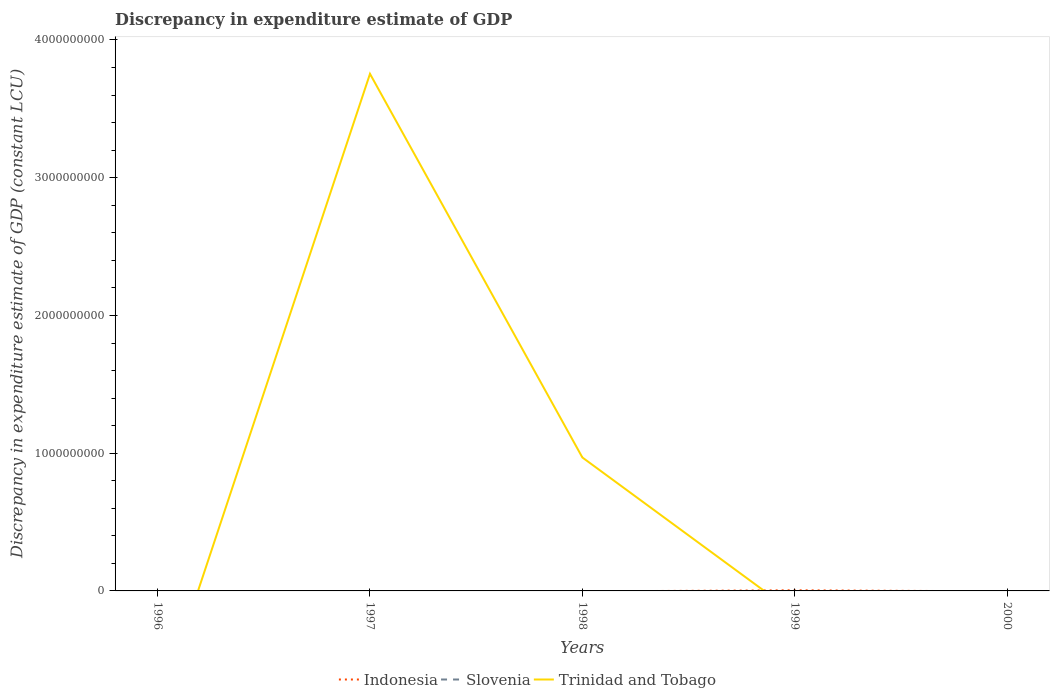How many different coloured lines are there?
Offer a terse response. 2. What is the difference between the highest and the second highest discrepancy in expenditure estimate of GDP in Trinidad and Tobago?
Offer a very short reply. 3.75e+09. What is the difference between the highest and the lowest discrepancy in expenditure estimate of GDP in Trinidad and Tobago?
Keep it short and to the point. 2. Is the discrepancy in expenditure estimate of GDP in Trinidad and Tobago strictly greater than the discrepancy in expenditure estimate of GDP in Slovenia over the years?
Offer a terse response. No. How many lines are there?
Provide a short and direct response. 2. How many years are there in the graph?
Your answer should be very brief. 5. What is the difference between two consecutive major ticks on the Y-axis?
Your answer should be compact. 1.00e+09. Are the values on the major ticks of Y-axis written in scientific E-notation?
Make the answer very short. No. Does the graph contain any zero values?
Make the answer very short. Yes. Where does the legend appear in the graph?
Make the answer very short. Bottom center. What is the title of the graph?
Your answer should be very brief. Discrepancy in expenditure estimate of GDP. Does "New Zealand" appear as one of the legend labels in the graph?
Make the answer very short. No. What is the label or title of the Y-axis?
Your response must be concise. Discrepancy in expenditure estimate of GDP (constant LCU). What is the Discrepancy in expenditure estimate of GDP (constant LCU) of Indonesia in 1996?
Provide a short and direct response. 0. What is the Discrepancy in expenditure estimate of GDP (constant LCU) in Trinidad and Tobago in 1996?
Make the answer very short. 0. What is the Discrepancy in expenditure estimate of GDP (constant LCU) in Indonesia in 1997?
Give a very brief answer. 0. What is the Discrepancy in expenditure estimate of GDP (constant LCU) of Slovenia in 1997?
Your answer should be very brief. 0. What is the Discrepancy in expenditure estimate of GDP (constant LCU) of Trinidad and Tobago in 1997?
Your answer should be compact. 3.75e+09. What is the Discrepancy in expenditure estimate of GDP (constant LCU) in Trinidad and Tobago in 1998?
Ensure brevity in your answer.  9.69e+08. What is the Discrepancy in expenditure estimate of GDP (constant LCU) in Indonesia in 1999?
Your answer should be compact. 4.65e+06. What is the Discrepancy in expenditure estimate of GDP (constant LCU) of Slovenia in 1999?
Your answer should be very brief. 0. What is the Discrepancy in expenditure estimate of GDP (constant LCU) of Indonesia in 2000?
Give a very brief answer. 0. What is the Discrepancy in expenditure estimate of GDP (constant LCU) in Slovenia in 2000?
Provide a succinct answer. 0. What is the Discrepancy in expenditure estimate of GDP (constant LCU) in Trinidad and Tobago in 2000?
Make the answer very short. 0. Across all years, what is the maximum Discrepancy in expenditure estimate of GDP (constant LCU) in Indonesia?
Offer a very short reply. 4.65e+06. Across all years, what is the maximum Discrepancy in expenditure estimate of GDP (constant LCU) of Trinidad and Tobago?
Ensure brevity in your answer.  3.75e+09. Across all years, what is the minimum Discrepancy in expenditure estimate of GDP (constant LCU) in Trinidad and Tobago?
Your answer should be very brief. 0. What is the total Discrepancy in expenditure estimate of GDP (constant LCU) of Indonesia in the graph?
Your answer should be compact. 4.65e+06. What is the total Discrepancy in expenditure estimate of GDP (constant LCU) in Trinidad and Tobago in the graph?
Your response must be concise. 4.72e+09. What is the difference between the Discrepancy in expenditure estimate of GDP (constant LCU) of Trinidad and Tobago in 1997 and that in 1998?
Ensure brevity in your answer.  2.79e+09. What is the average Discrepancy in expenditure estimate of GDP (constant LCU) in Indonesia per year?
Offer a very short reply. 9.30e+05. What is the average Discrepancy in expenditure estimate of GDP (constant LCU) in Trinidad and Tobago per year?
Make the answer very short. 9.45e+08. What is the ratio of the Discrepancy in expenditure estimate of GDP (constant LCU) in Trinidad and Tobago in 1997 to that in 1998?
Keep it short and to the point. 3.87. What is the difference between the highest and the lowest Discrepancy in expenditure estimate of GDP (constant LCU) of Indonesia?
Make the answer very short. 4.65e+06. What is the difference between the highest and the lowest Discrepancy in expenditure estimate of GDP (constant LCU) of Trinidad and Tobago?
Your answer should be compact. 3.75e+09. 